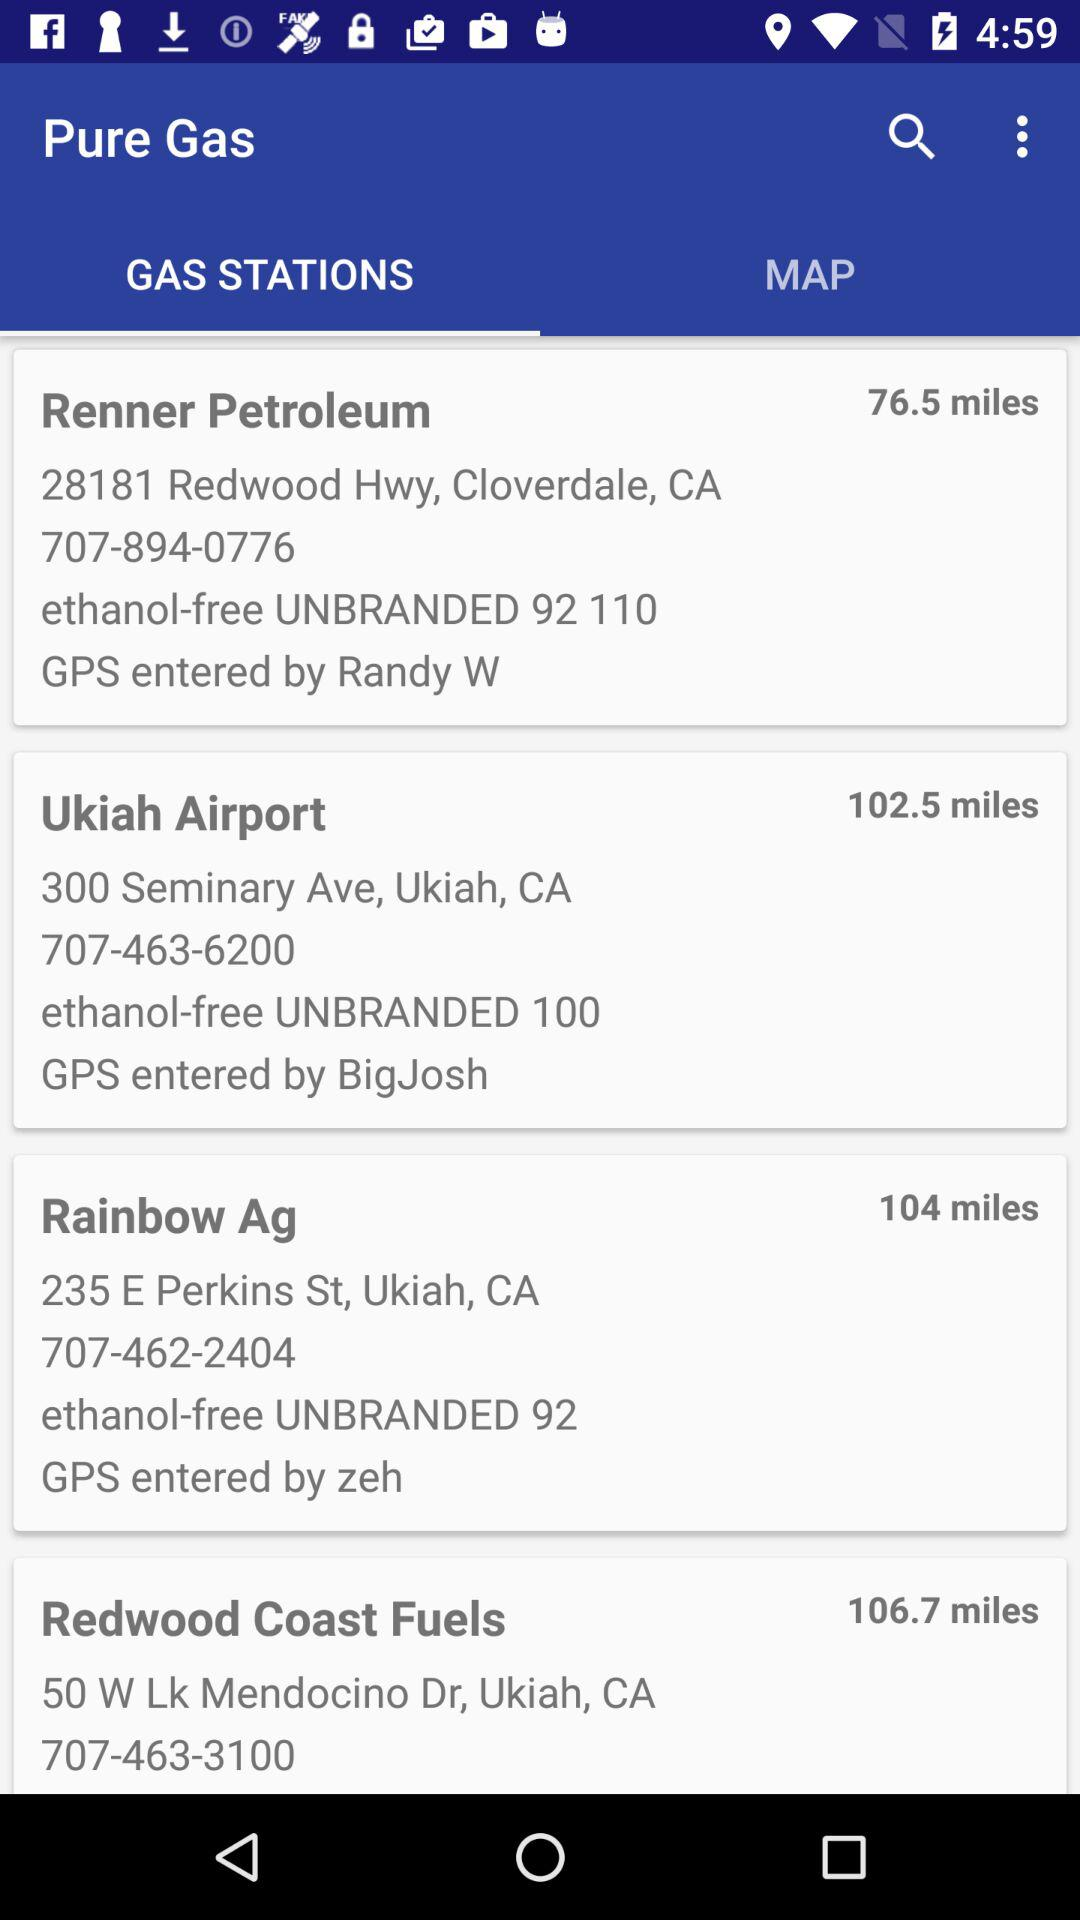How far is the Rainbow Ag? The Rainbow Ag is 104 miles away. 